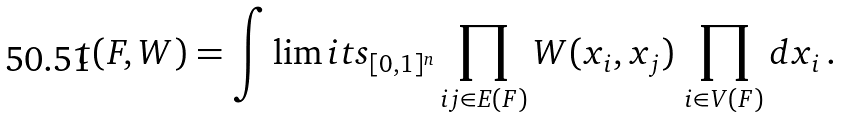<formula> <loc_0><loc_0><loc_500><loc_500>t ( F , W ) = \int \lim i t s _ { [ 0 , 1 ] ^ { n } } \prod _ { i j \in E ( F ) } W ( x _ { i } , x _ { j } ) \, \prod _ { i \in V ( F ) } d x _ { i } \, .</formula> 